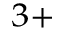<formula> <loc_0><loc_0><loc_500><loc_500>^ { 3 + }</formula> 